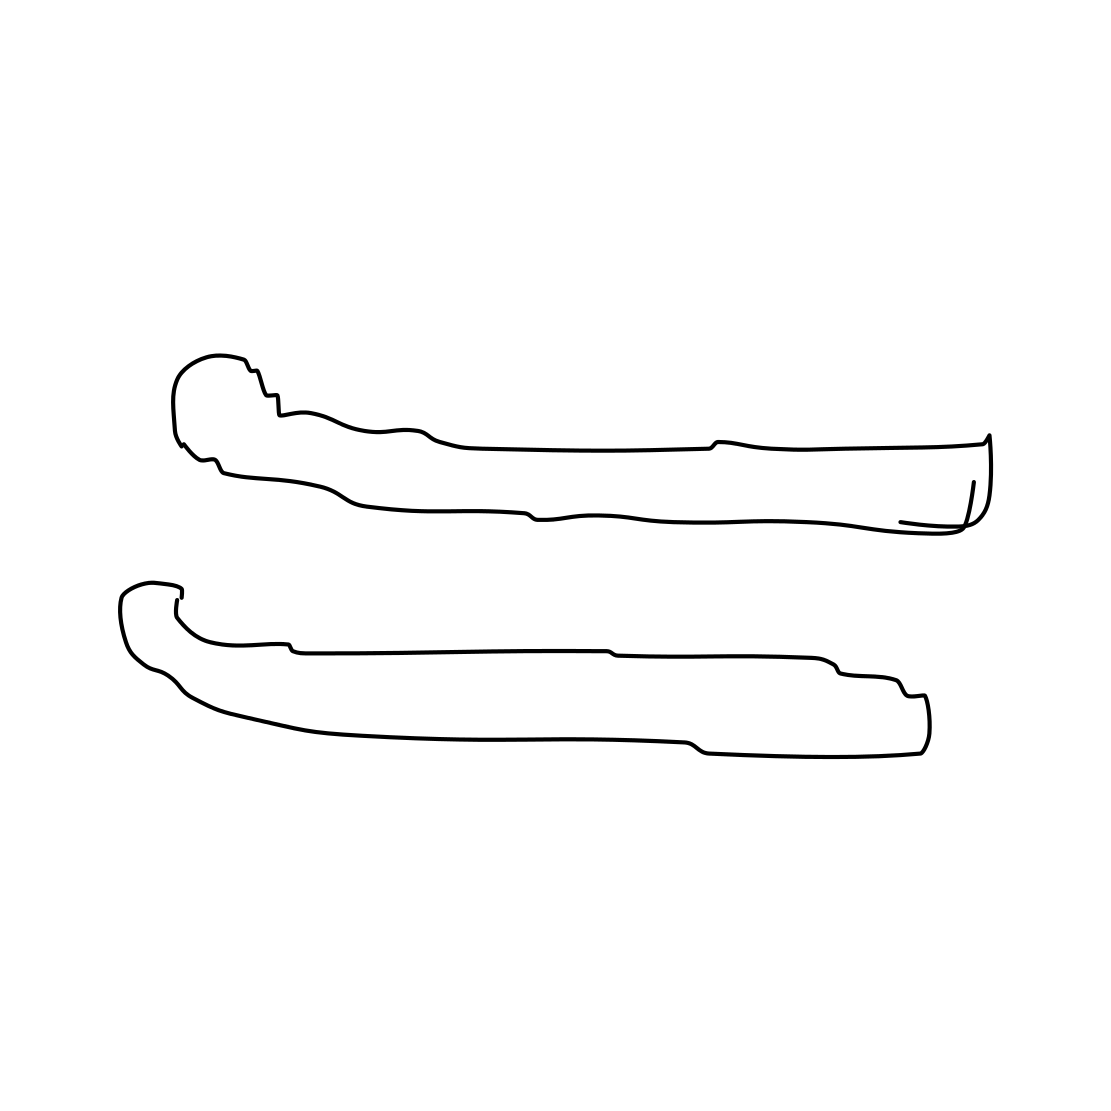Could these objects symbolize something in a cultural context? Without explicit cultural reference points, it’s speculative, but one could interpret these objects as symbolic. Their parallel arrangement and the curvature might suggest harmony and balance, often themes in various cultures. Alternatively, they could be seen as tools which might signify work and creativity. The beauty of abstract illustrations lies in their versatility for different interpretations. 